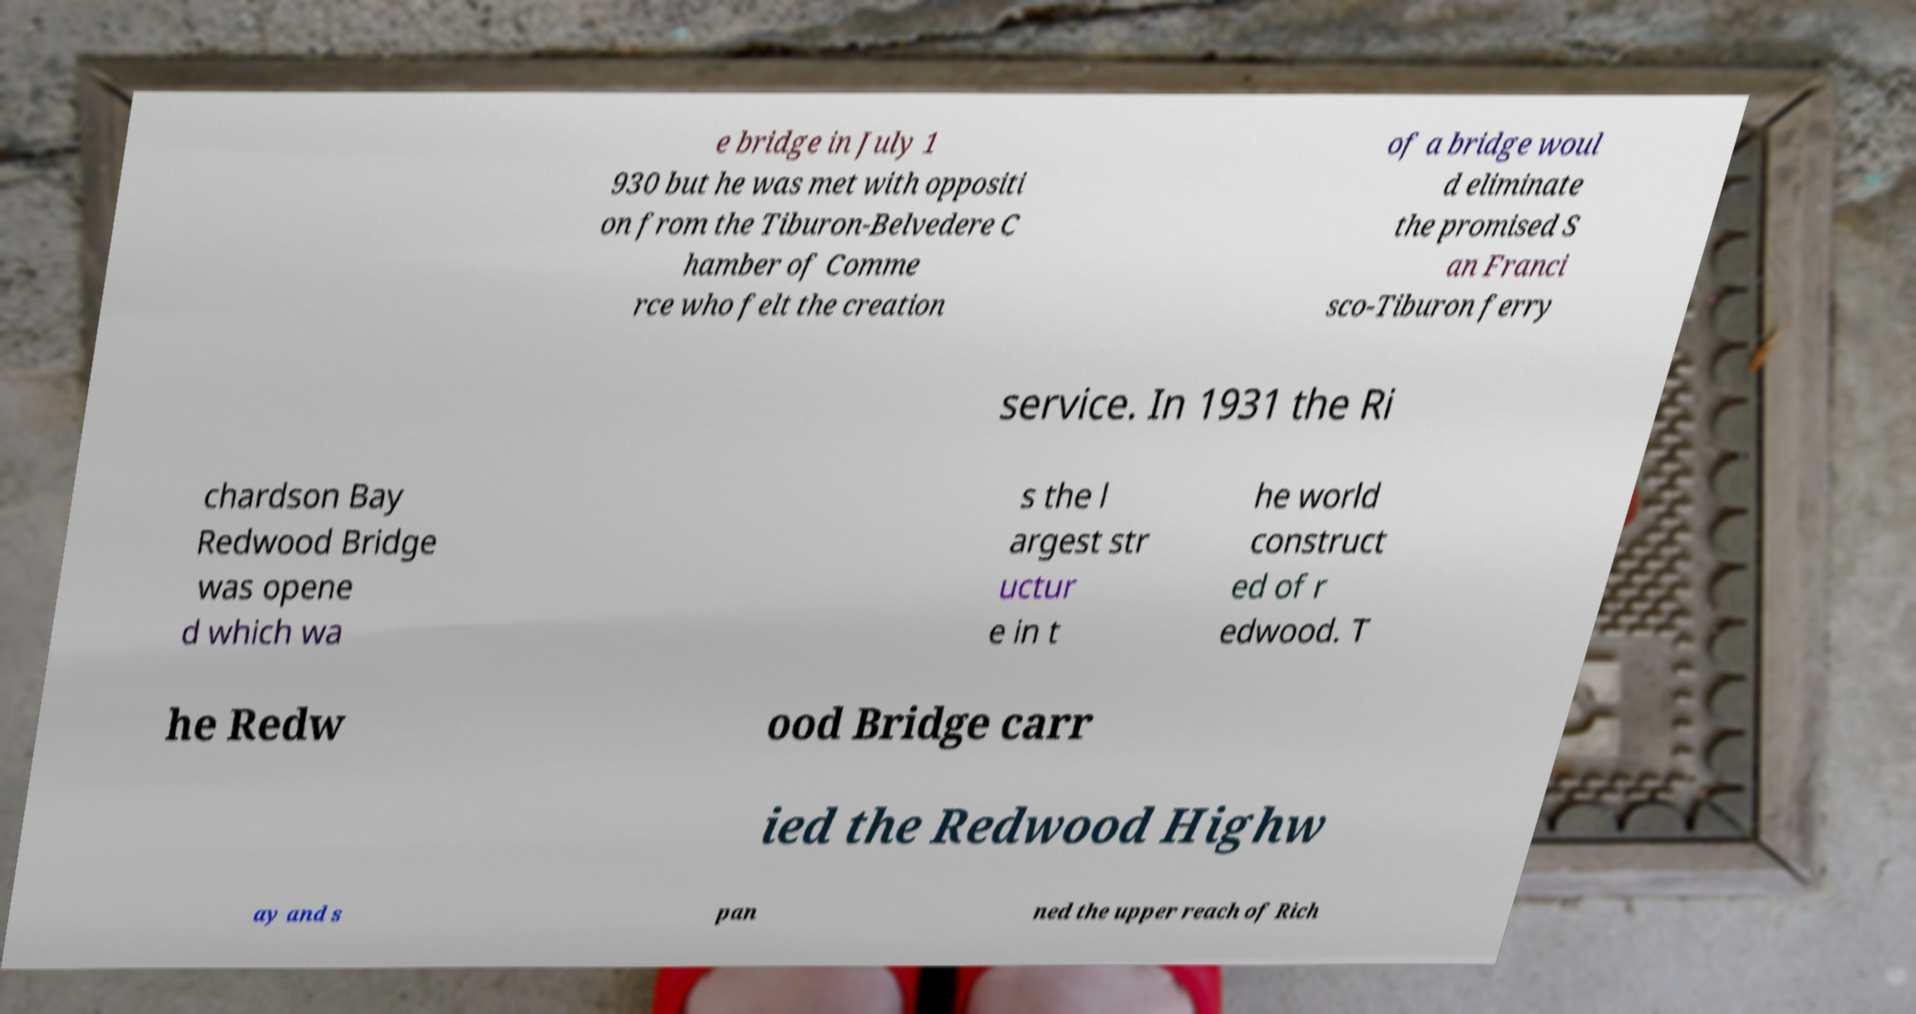Could you extract and type out the text from this image? e bridge in July 1 930 but he was met with oppositi on from the Tiburon-Belvedere C hamber of Comme rce who felt the creation of a bridge woul d eliminate the promised S an Franci sco-Tiburon ferry service. In 1931 the Ri chardson Bay Redwood Bridge was opene d which wa s the l argest str uctur e in t he world construct ed of r edwood. T he Redw ood Bridge carr ied the Redwood Highw ay and s pan ned the upper reach of Rich 